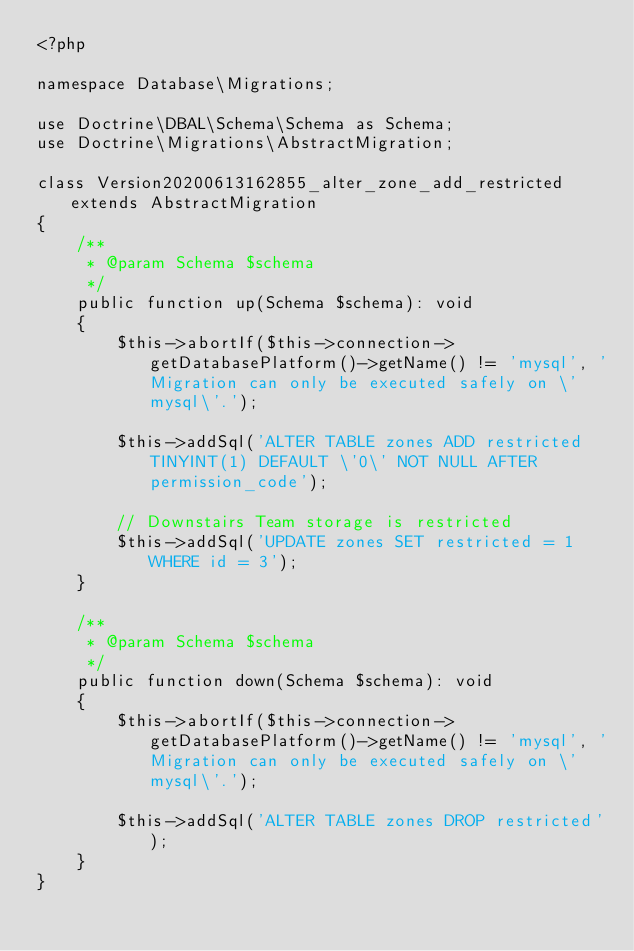Convert code to text. <code><loc_0><loc_0><loc_500><loc_500><_PHP_><?php

namespace Database\Migrations;

use Doctrine\DBAL\Schema\Schema as Schema;
use Doctrine\Migrations\AbstractMigration;

class Version20200613162855_alter_zone_add_restricted extends AbstractMigration
{
    /**
     * @param Schema $schema
     */
    public function up(Schema $schema): void
    {
        $this->abortIf($this->connection->getDatabasePlatform()->getName() != 'mysql', 'Migration can only be executed safely on \'mysql\'.');

        $this->addSql('ALTER TABLE zones ADD restricted TINYINT(1) DEFAULT \'0\' NOT NULL AFTER permission_code');

        // Downstairs Team storage is restricted
        $this->addSql('UPDATE zones SET restricted = 1 WHERE id = 3');
    }

    /**
     * @param Schema $schema
     */
    public function down(Schema $schema): void
    {
        $this->abortIf($this->connection->getDatabasePlatform()->getName() != 'mysql', 'Migration can only be executed safely on \'mysql\'.');

        $this->addSql('ALTER TABLE zones DROP restricted');
    }
}
</code> 